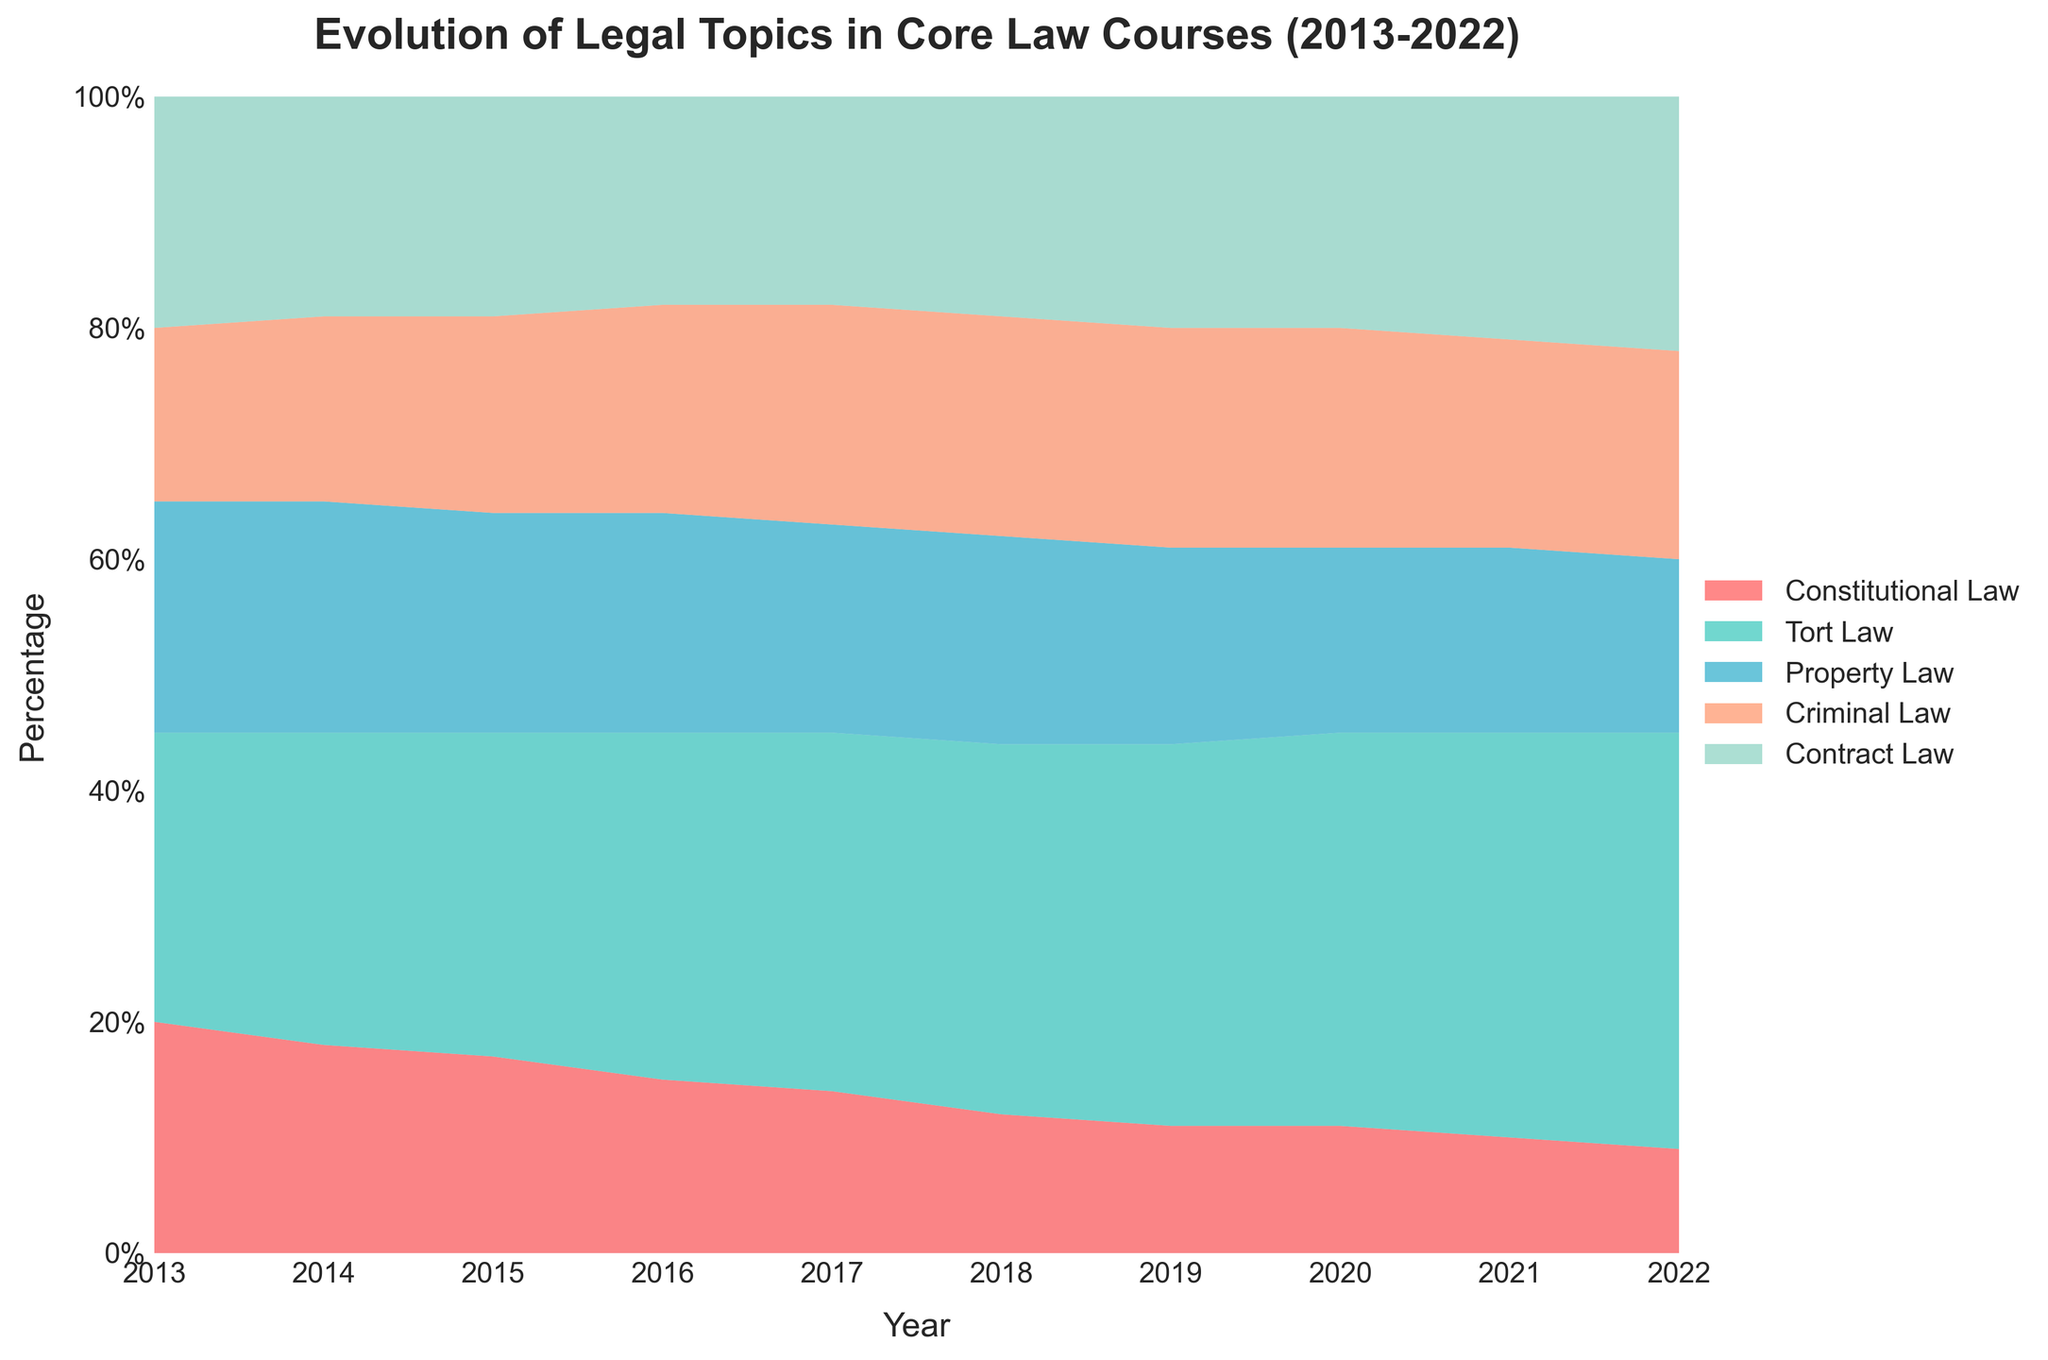What is the title of the figure? The title is located at the top of the figure and is typically in a larger and bolder font than other text.
Answer: Evolution of Legal Topics in Core Law Courses (2013-2022) How many legal topics are represented in the figure? The legend to the right of the figure lists all the legal topics represented by different colors.
Answer: Five Which legal topic had the highest percentage in 2022? By looking at the stacked areas in the figure for the year 2022, we can see which color occupies the largest space vertically.
Answer: Tort Law How did the percentage of Constitutional Law change from 2013 to 2022? Measure the height of the red area representing Constitutional Law at both ends of the x-axis and compare the two values. In 2013, it is around 20%, and in 2022, it is around 9%. The decrease is 20% - 9% = 11%.
Answer: Decreased by 11% Compare the percentage change of Contract Law from 2013 to 2022 with that of Tort Law. Which increased more? Contract Law increased from around 20% to around 22% (an increase of 2%), whereas Tort Law increased from around 25% to around 36% (an increase of 11%). By comparing these two changes, it's clear Tort Law increased more.
Answer: Tort Law Which legal topic remained relatively stable over the period 2013-2022? Examine each colored area to identify which one had the smallest variation in vertical space throughout the years.
Answer: Criminal Law What is the combined percentage of Property Law and Criminal Law in the year 2020? Look at the heights of the areas corresponding to Property Law and Criminal Law in 2020 and add them up. Property Law is about 16%, and Criminal Law is about 19%, so the combined percentage is 16% + 19% = 35%.
Answer: 35% Was there a year when Constitutional Law and Tort Law together made up 50% of the total topics? If so, which year? Analyze the figure for each year to identify when the combined height of the areas representing Constitutional Law and Tort Law reached 50%. In 2013, they add up to 45%, and no year has them combined at exactly 50%.
Answer: No How did the percentage composition of Criminal Law change from 2016 to 2017? Identify the height of the Criminal Law section for both 2016 and 2017 and find the difference. In both years, it remains constant at around 19%.
Answer: No change What is the percentage difference between the topics with the highest and lowest representation in 2021? In 2021, the highest is Tort Law (35%), and the lowest is Constitutional Law (10%). The difference is 35% - 10% = 25%.
Answer: 25% 